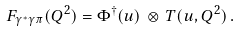Convert formula to latex. <formula><loc_0><loc_0><loc_500><loc_500>F _ { \gamma ^ { * } \gamma \pi } ( Q ^ { 2 } ) = \Phi ^ { \dagger } ( u ) \, \otimes \, T ( u , Q ^ { 2 } ) \, .</formula> 